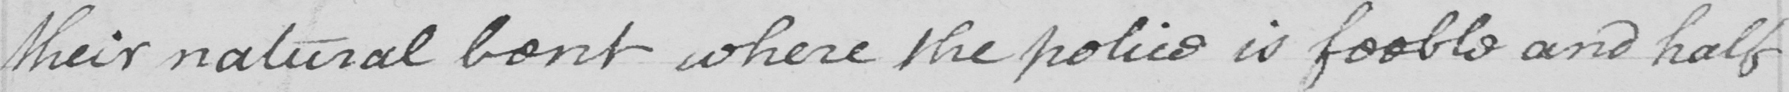What text is written in this handwritten line? their natural bent where the police is feeble and half 